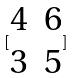<formula> <loc_0><loc_0><loc_500><loc_500>[ \begin{matrix} 4 & 6 \\ 3 & 5 \end{matrix} ]</formula> 